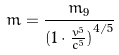<formula> <loc_0><loc_0><loc_500><loc_500>m = \frac { m _ { 9 } } { ( { 1 \cdot \frac { v ^ { 5 } } { c ^ { 5 } } ) } ^ { 4 / 5 } }</formula> 